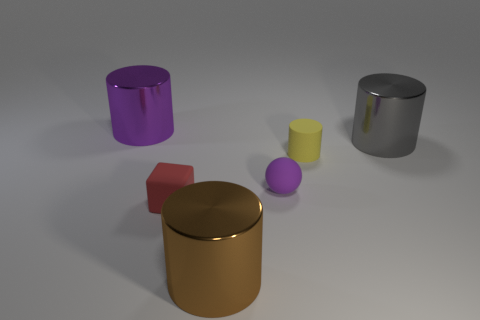How many other things are the same size as the purple metallic cylinder?
Your answer should be very brief. 2. The yellow matte cylinder has what size?
Provide a succinct answer. Small. Is the material of the large object that is in front of the large gray shiny object the same as the small purple ball?
Keep it short and to the point. No. There is another tiny rubber object that is the same shape as the brown thing; what color is it?
Make the answer very short. Yellow. Does the metal cylinder to the left of the brown shiny cylinder have the same color as the ball?
Offer a terse response. Yes. There is a small red block; are there any big gray things to the right of it?
Your response must be concise. Yes. What color is the cylinder that is in front of the big purple shiny cylinder and behind the yellow rubber thing?
Make the answer very short. Gray. There is a large object that is the same color as the rubber sphere; what shape is it?
Provide a succinct answer. Cylinder. What is the size of the metal thing in front of the rubber thing right of the small purple object?
Offer a terse response. Large. How many cylinders are gray objects or brown metal things?
Your answer should be very brief. 2. 